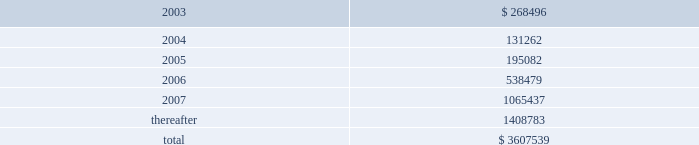American tower corporation and subsidiaries notes to consolidated financial statements 2014 ( continued ) 19 .
Subsequent events 12.25% ( 12.25 % ) senior subordinated discount notes and warrants offering 2014in january 2003 , the company issued 808000 units , each consisting of ( 1 ) $ 1000 principal amount at maturity of the 12.25% ( 12.25 % ) senior subordinated discount notes due 2008 of a wholly owned subsidiary of the company ( ati notes ) and ( 2 ) a warrant to purchase 14.0953 shares of class a common stock of the company , for gross proceeds of $ 420.0 million .
The gross offering proceeds were allocated between the ati notes ( $ 367.4 million ) and the fair value of the warrants ( $ 52.6 million ) .
Net proceeds from the offering aggregated approximately $ 397.0 million and were or will be used for the purposes described below under amended and restated loan agreement .
The ati notes accrue no cash interest .
Instead , the accreted value of each ati note will increase between the date of original issuance and maturity ( august 1 , 2008 ) at a rate of 12.25% ( 12.25 % ) per annum .
The 808000 warrants that were issued together with the ati notes each represent the right to purchase 14.0953 shares of class a common stock at $ 0.01 per share .
The warrants are exercisable at any time on or after january 29 , 2006 and will expire on august 1 , 2008 .
As of the issuance date , the warrants represented approximately 5.5% ( 5.5 % ) of the company 2019s outstanding common stock ( assuming exercise of all warrants ) .
The indenture governing the ati notes contains covenants that , among other things , limit the ability of the issuer subsidiary and its guarantors to incur or guarantee additional indebtedness , create liens , pay dividends or make other equity distributions , enter into agreements restricting the restricted subsidiaries 2019 ability to pay dividends , purchase or redeem capital stock , make investments and sell assets or consolidate or merge with or into other companies .
The ati notes rank junior in right of payment to all existing and future senior indebtedness , including all indebtedness outstanding under the credit facilities , and are structurally senior in right of payment to all existing and future indebtedness of the company .
Amended and restated loan agreement 2014on february 21 , 2003 , the company completed an amendment to its credit facilities .
The amendment provides for the following : 2022 prepayment of a portion of outstanding term loans .
The company agreed to prepay an aggregate of $ 200.0 million of the term loans outstanding under the credit facilities from a portion of the net proceeds of the ati notes offering completed in january 2003 .
This prepayment consisted of a $ 125.0 million prepayment of the term loan a and a $ 75.0 million prepayment of the term loan b , each to be applied to reduce future scheduled principal payments .
Giving effect to the prepayment of $ 200.0 million of term loans under the credit facility and the issuance of the ati notes as discussed above as well as the paydown of debt from net proceeds of the sale of mtn ( $ 24.5 million in february 2003 ) , the company 2019s aggregate principal payments of long- term debt , including capital leases , for the next five years and thereafter are as follows ( in thousands ) : year ending december 31 .

What is the total expected payments for principal of long- term debt , including capital leases in the next 24 months? 
Computations: (268496 + 131262)
Answer: 399758.0. American tower corporation and subsidiaries notes to consolidated financial statements 2014 ( continued ) 19 .
Subsequent events 12.25% ( 12.25 % ) senior subordinated discount notes and warrants offering 2014in january 2003 , the company issued 808000 units , each consisting of ( 1 ) $ 1000 principal amount at maturity of the 12.25% ( 12.25 % ) senior subordinated discount notes due 2008 of a wholly owned subsidiary of the company ( ati notes ) and ( 2 ) a warrant to purchase 14.0953 shares of class a common stock of the company , for gross proceeds of $ 420.0 million .
The gross offering proceeds were allocated between the ati notes ( $ 367.4 million ) and the fair value of the warrants ( $ 52.6 million ) .
Net proceeds from the offering aggregated approximately $ 397.0 million and were or will be used for the purposes described below under amended and restated loan agreement .
The ati notes accrue no cash interest .
Instead , the accreted value of each ati note will increase between the date of original issuance and maturity ( august 1 , 2008 ) at a rate of 12.25% ( 12.25 % ) per annum .
The 808000 warrants that were issued together with the ati notes each represent the right to purchase 14.0953 shares of class a common stock at $ 0.01 per share .
The warrants are exercisable at any time on or after january 29 , 2006 and will expire on august 1 , 2008 .
As of the issuance date , the warrants represented approximately 5.5% ( 5.5 % ) of the company 2019s outstanding common stock ( assuming exercise of all warrants ) .
The indenture governing the ati notes contains covenants that , among other things , limit the ability of the issuer subsidiary and its guarantors to incur or guarantee additional indebtedness , create liens , pay dividends or make other equity distributions , enter into agreements restricting the restricted subsidiaries 2019 ability to pay dividends , purchase or redeem capital stock , make investments and sell assets or consolidate or merge with or into other companies .
The ati notes rank junior in right of payment to all existing and future senior indebtedness , including all indebtedness outstanding under the credit facilities , and are structurally senior in right of payment to all existing and future indebtedness of the company .
Amended and restated loan agreement 2014on february 21 , 2003 , the company completed an amendment to its credit facilities .
The amendment provides for the following : 2022 prepayment of a portion of outstanding term loans .
The company agreed to prepay an aggregate of $ 200.0 million of the term loans outstanding under the credit facilities from a portion of the net proceeds of the ati notes offering completed in january 2003 .
This prepayment consisted of a $ 125.0 million prepayment of the term loan a and a $ 75.0 million prepayment of the term loan b , each to be applied to reduce future scheduled principal payments .
Giving effect to the prepayment of $ 200.0 million of term loans under the credit facility and the issuance of the ati notes as discussed above as well as the paydown of debt from net proceeds of the sale of mtn ( $ 24.5 million in february 2003 ) , the company 2019s aggregate principal payments of long- term debt , including capital leases , for the next five years and thereafter are as follows ( in thousands ) : year ending december 31 .

What is the total expected payments for principal of long- term debt , including capital leases in the next 36 months? 
Computations: ((268496 + 131262) + 195082)
Answer: 594840.0. 